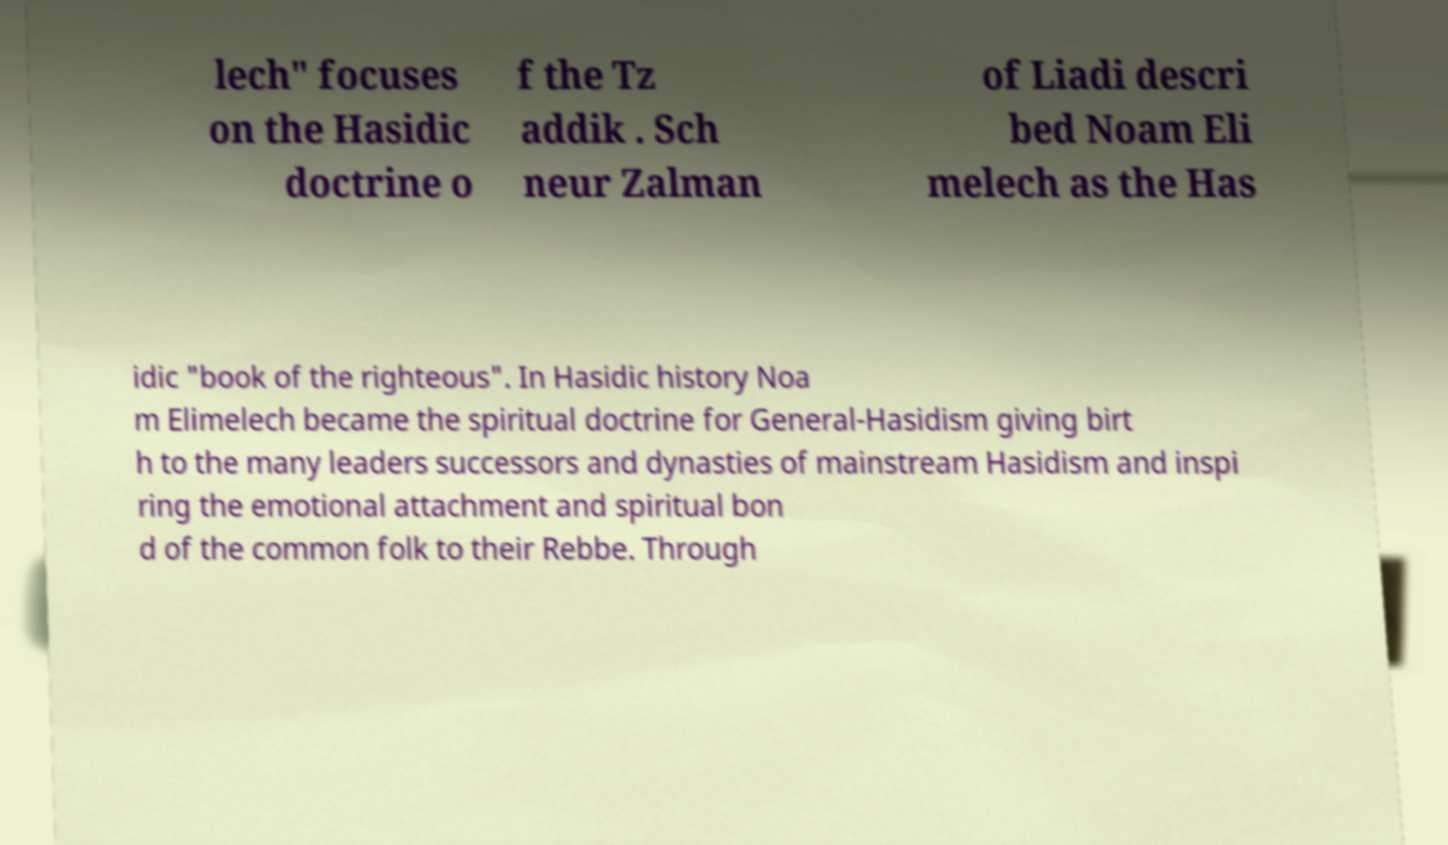Can you read and provide the text displayed in the image?This photo seems to have some interesting text. Can you extract and type it out for me? lech" focuses on the Hasidic doctrine o f the Tz addik . Sch neur Zalman of Liadi descri bed Noam Eli melech as the Has idic "book of the righteous". In Hasidic history Noa m Elimelech became the spiritual doctrine for General-Hasidism giving birt h to the many leaders successors and dynasties of mainstream Hasidism and inspi ring the emotional attachment and spiritual bon d of the common folk to their Rebbe. Through 